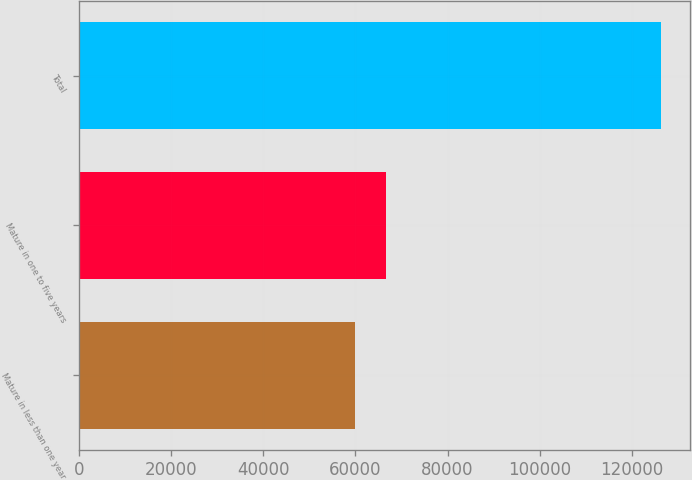Convert chart. <chart><loc_0><loc_0><loc_500><loc_500><bar_chart><fcel>Mature in less than one year<fcel>Mature in one to five years<fcel>Total<nl><fcel>59900<fcel>66536.7<fcel>126267<nl></chart> 